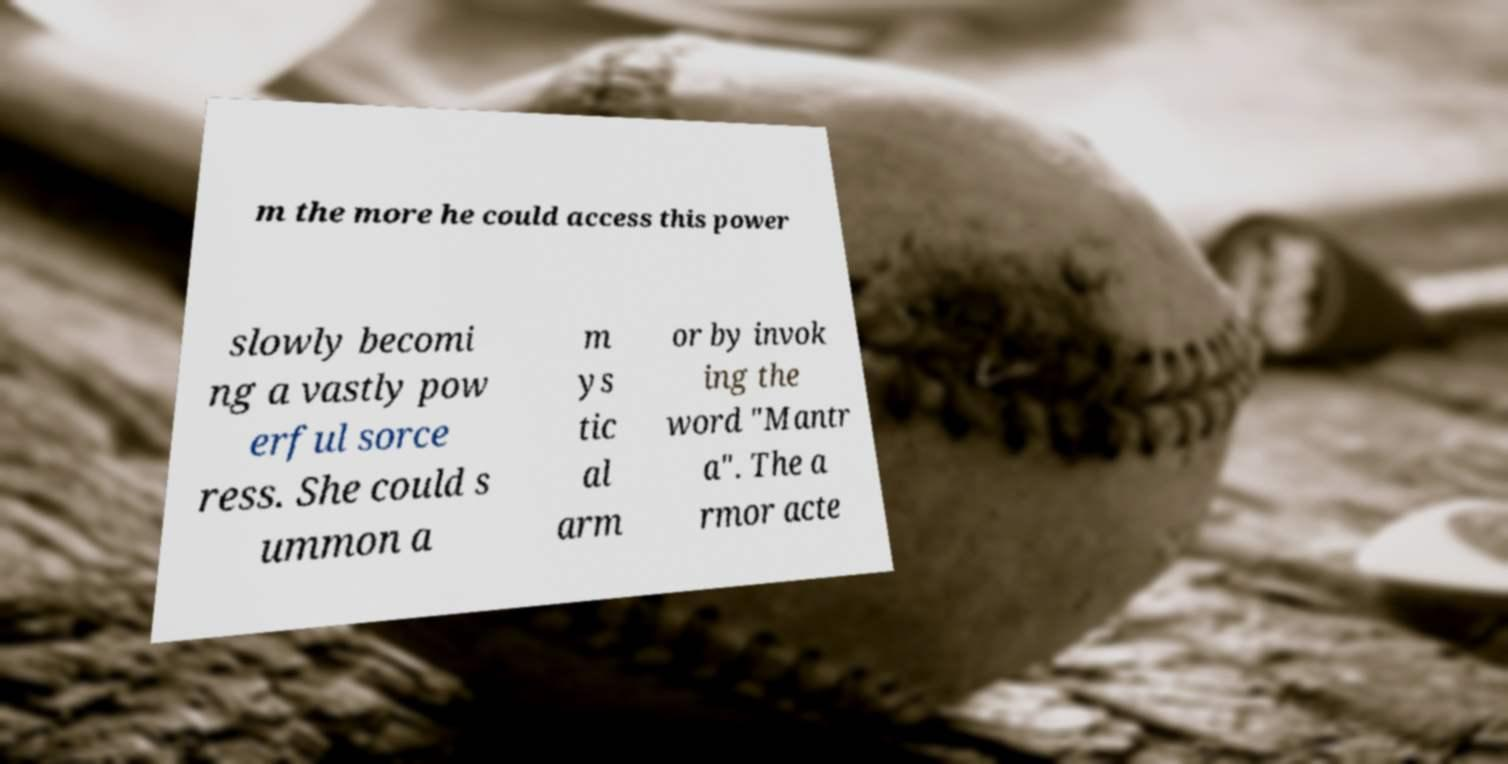Could you assist in decoding the text presented in this image and type it out clearly? m the more he could access this power slowly becomi ng a vastly pow erful sorce ress. She could s ummon a m ys tic al arm or by invok ing the word "Mantr a". The a rmor acte 